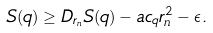Convert formula to latex. <formula><loc_0><loc_0><loc_500><loc_500>S ( q ) \geq D _ { r _ { n } } S ( q ) - a c _ { q } r _ { n } ^ { 2 } - \epsilon .</formula> 